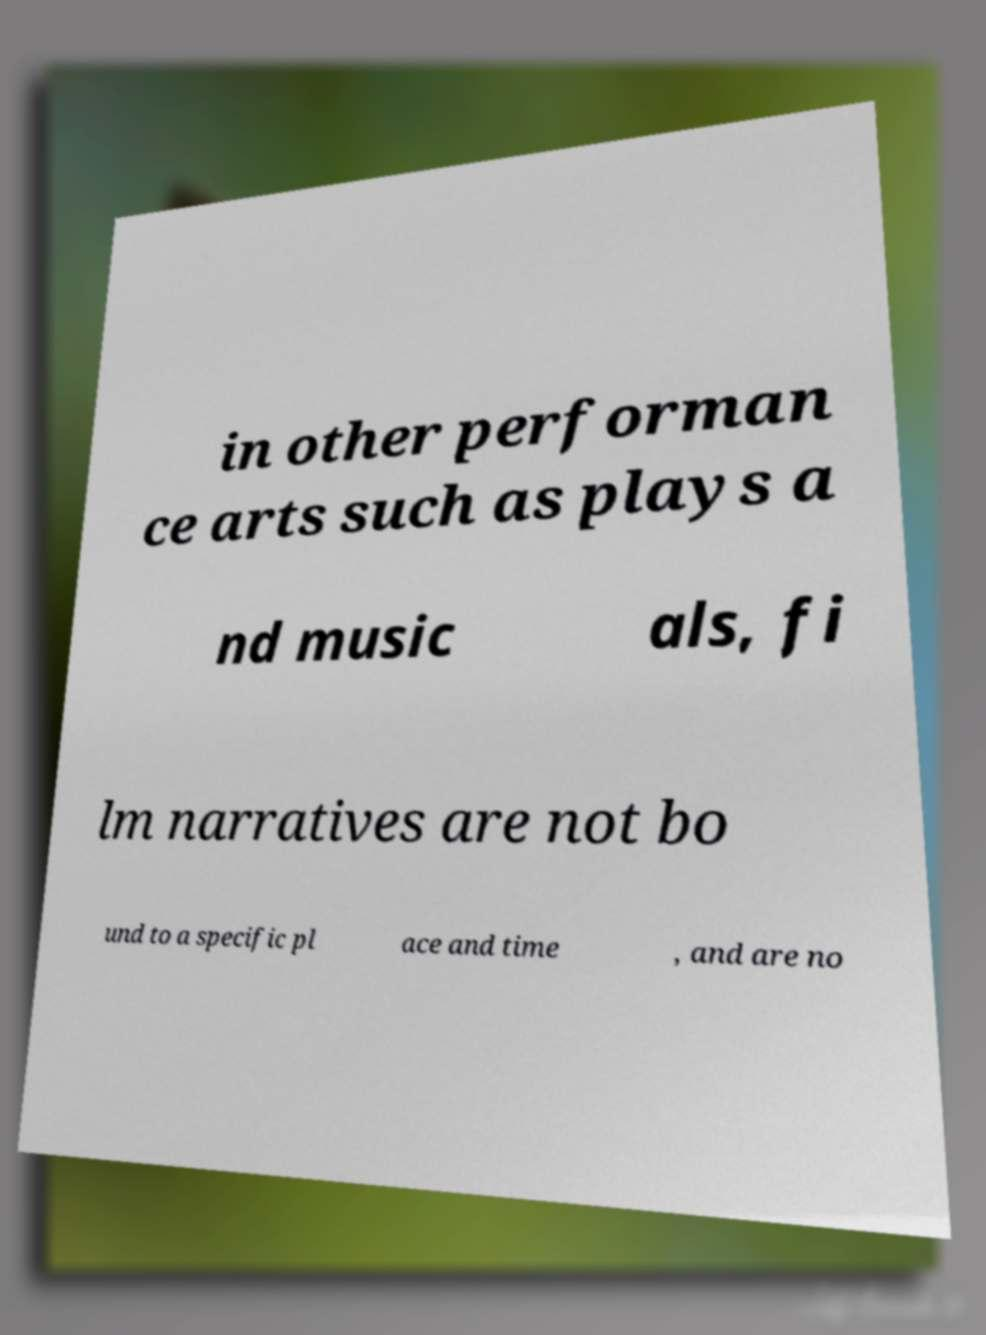For documentation purposes, I need the text within this image transcribed. Could you provide that? in other performan ce arts such as plays a nd music als, fi lm narratives are not bo und to a specific pl ace and time , and are no 